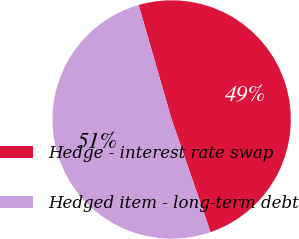<chart> <loc_0><loc_0><loc_500><loc_500><pie_chart><fcel>Hedge - interest rate swap<fcel>Hedged item - long-term debt<nl><fcel>49.18%<fcel>50.82%<nl></chart> 